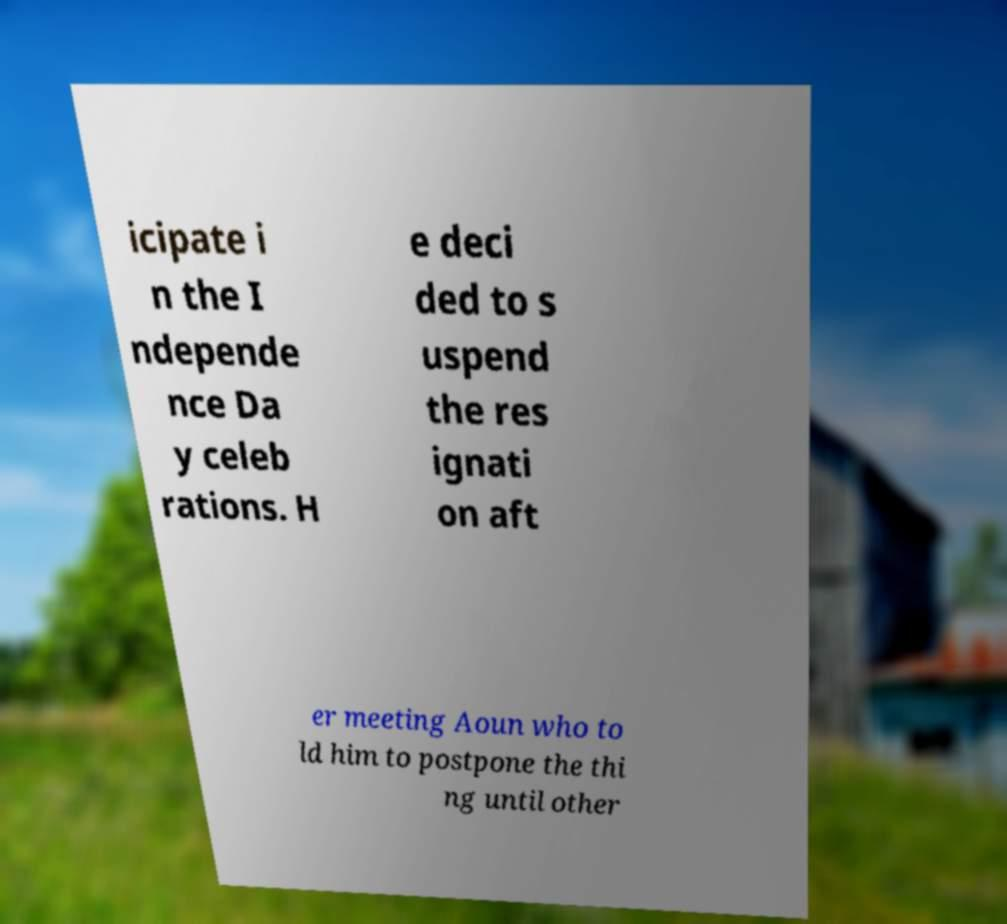Can you read and provide the text displayed in the image?This photo seems to have some interesting text. Can you extract and type it out for me? icipate i n the I ndepende nce Da y celeb rations. H e deci ded to s uspend the res ignati on aft er meeting Aoun who to ld him to postpone the thi ng until other 